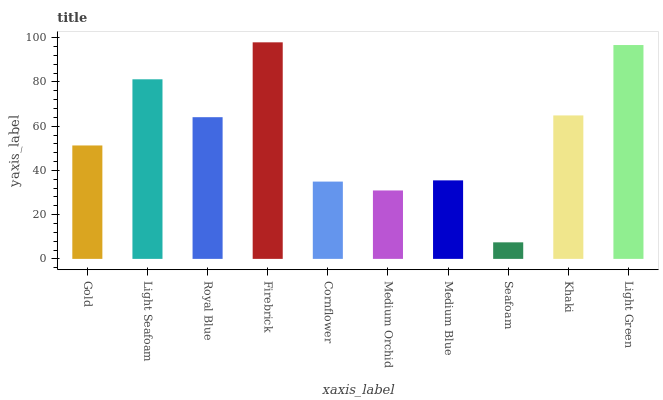Is Seafoam the minimum?
Answer yes or no. Yes. Is Firebrick the maximum?
Answer yes or no. Yes. Is Light Seafoam the minimum?
Answer yes or no. No. Is Light Seafoam the maximum?
Answer yes or no. No. Is Light Seafoam greater than Gold?
Answer yes or no. Yes. Is Gold less than Light Seafoam?
Answer yes or no. Yes. Is Gold greater than Light Seafoam?
Answer yes or no. No. Is Light Seafoam less than Gold?
Answer yes or no. No. Is Royal Blue the high median?
Answer yes or no. Yes. Is Gold the low median?
Answer yes or no. Yes. Is Light Seafoam the high median?
Answer yes or no. No. Is Medium Blue the low median?
Answer yes or no. No. 